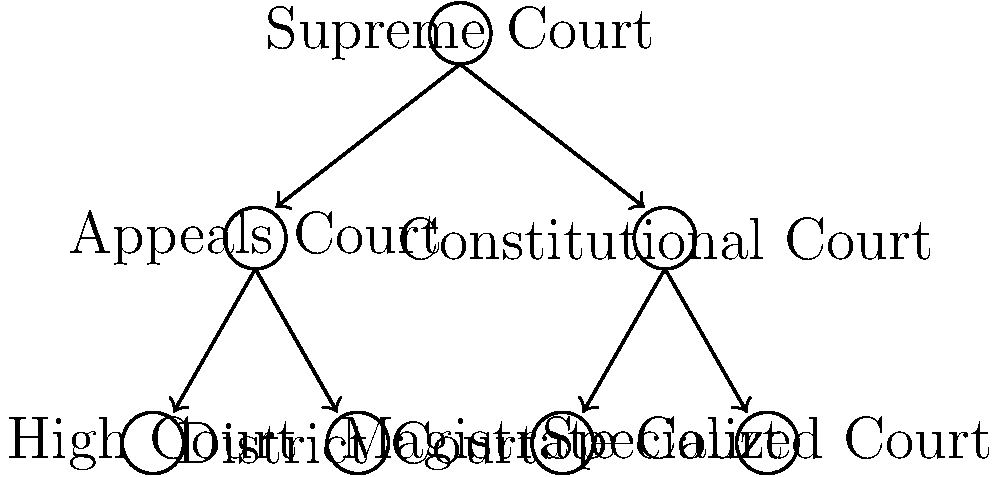In the hierarchical structure of a legal system represented by the tree diagram, how many direct children does the Appeals Court have? To answer this question, we need to examine the tree diagram and follow these steps:

1. Locate the "Appeals Court" node in the diagram.
2. Identify the nodes that are directly connected below the Appeals Court.
3. Count the number of these direct connections.

Looking at the diagram:
1. We can see the "Appeals Court" node on the left side of the second level.
2. There are two nodes directly connected below the Appeals Court:
   a. "High Court"
   b. "District Court"
3. Counting these direct connections, we find that there are 2 nodes.

In graph theory terms, these directly connected lower-level nodes are called "children" of the parent node (Appeals Court in this case).

Therefore, the Appeals Court has 2 direct children in this hierarchical structure.
Answer: 2 